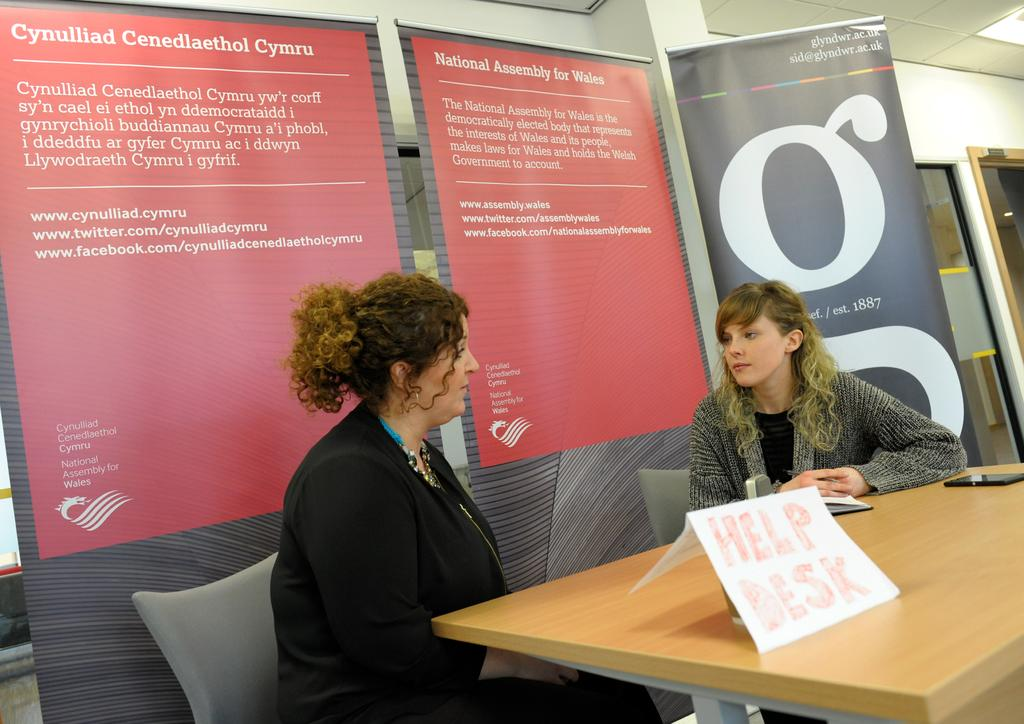How many people are in the image? There are two lady persons in the image. What are the lady persons doing in the image? The lady persons are sitting on a help desk. What object can be seen on the right side of the image? There is a phone on the right side of the image. What is visible in the background of the image? There is a banner in the background of the image. How many eggs are on the help desk in the image? There are no eggs present on the help desk in the image. What type of pet can be seen interacting with the lady persons in the image? There is no pet present in the image; it only features the two lady persons and a phone. 